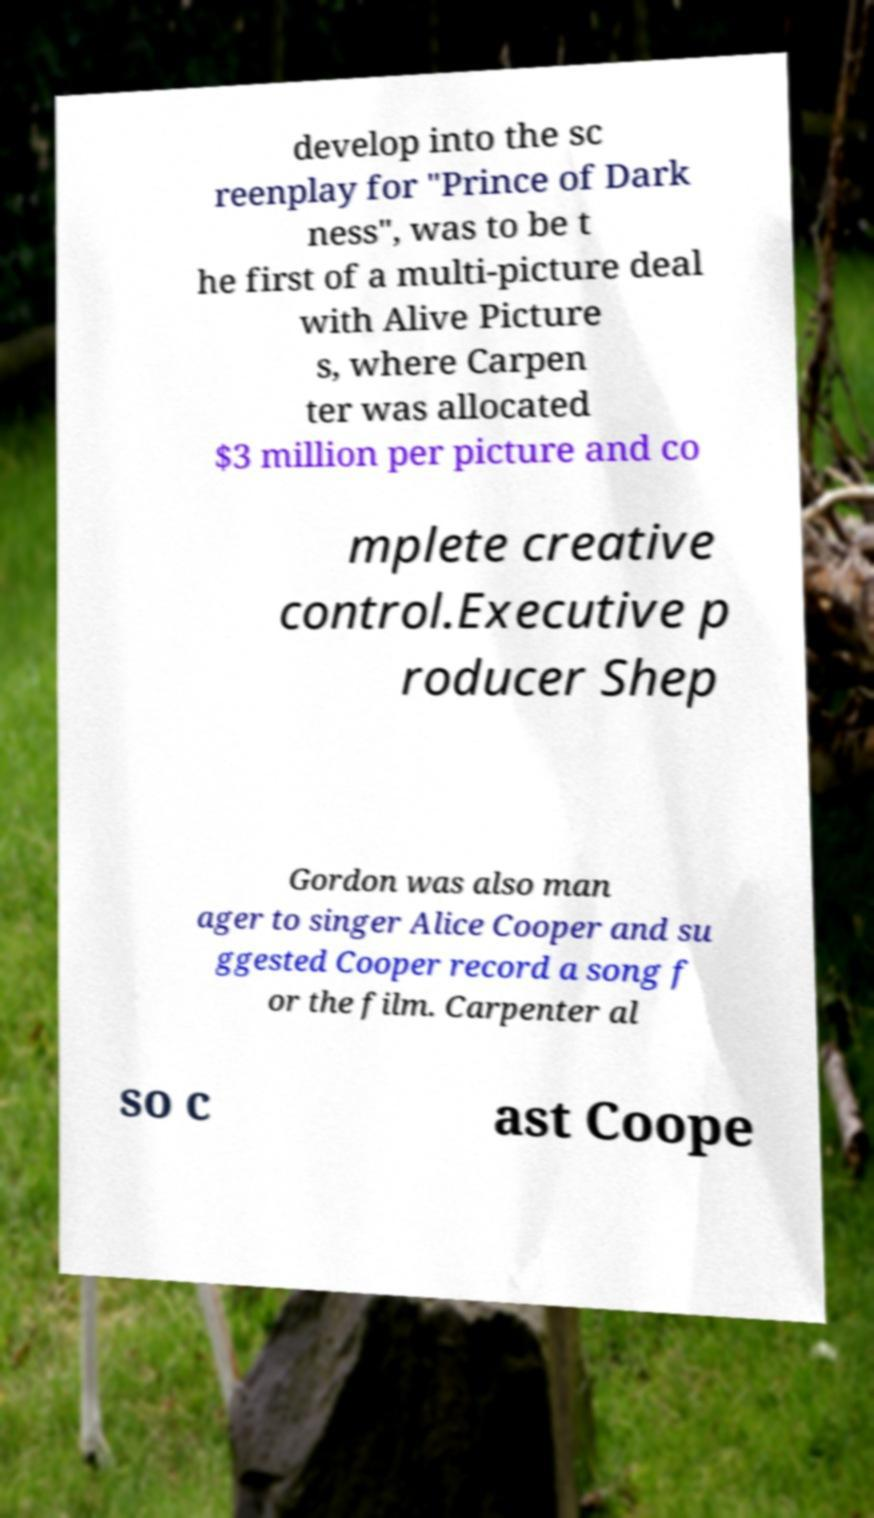I need the written content from this picture converted into text. Can you do that? develop into the sc reenplay for "Prince of Dark ness", was to be t he first of a multi-picture deal with Alive Picture s, where Carpen ter was allocated $3 million per picture and co mplete creative control.Executive p roducer Shep Gordon was also man ager to singer Alice Cooper and su ggested Cooper record a song f or the film. Carpenter al so c ast Coope 